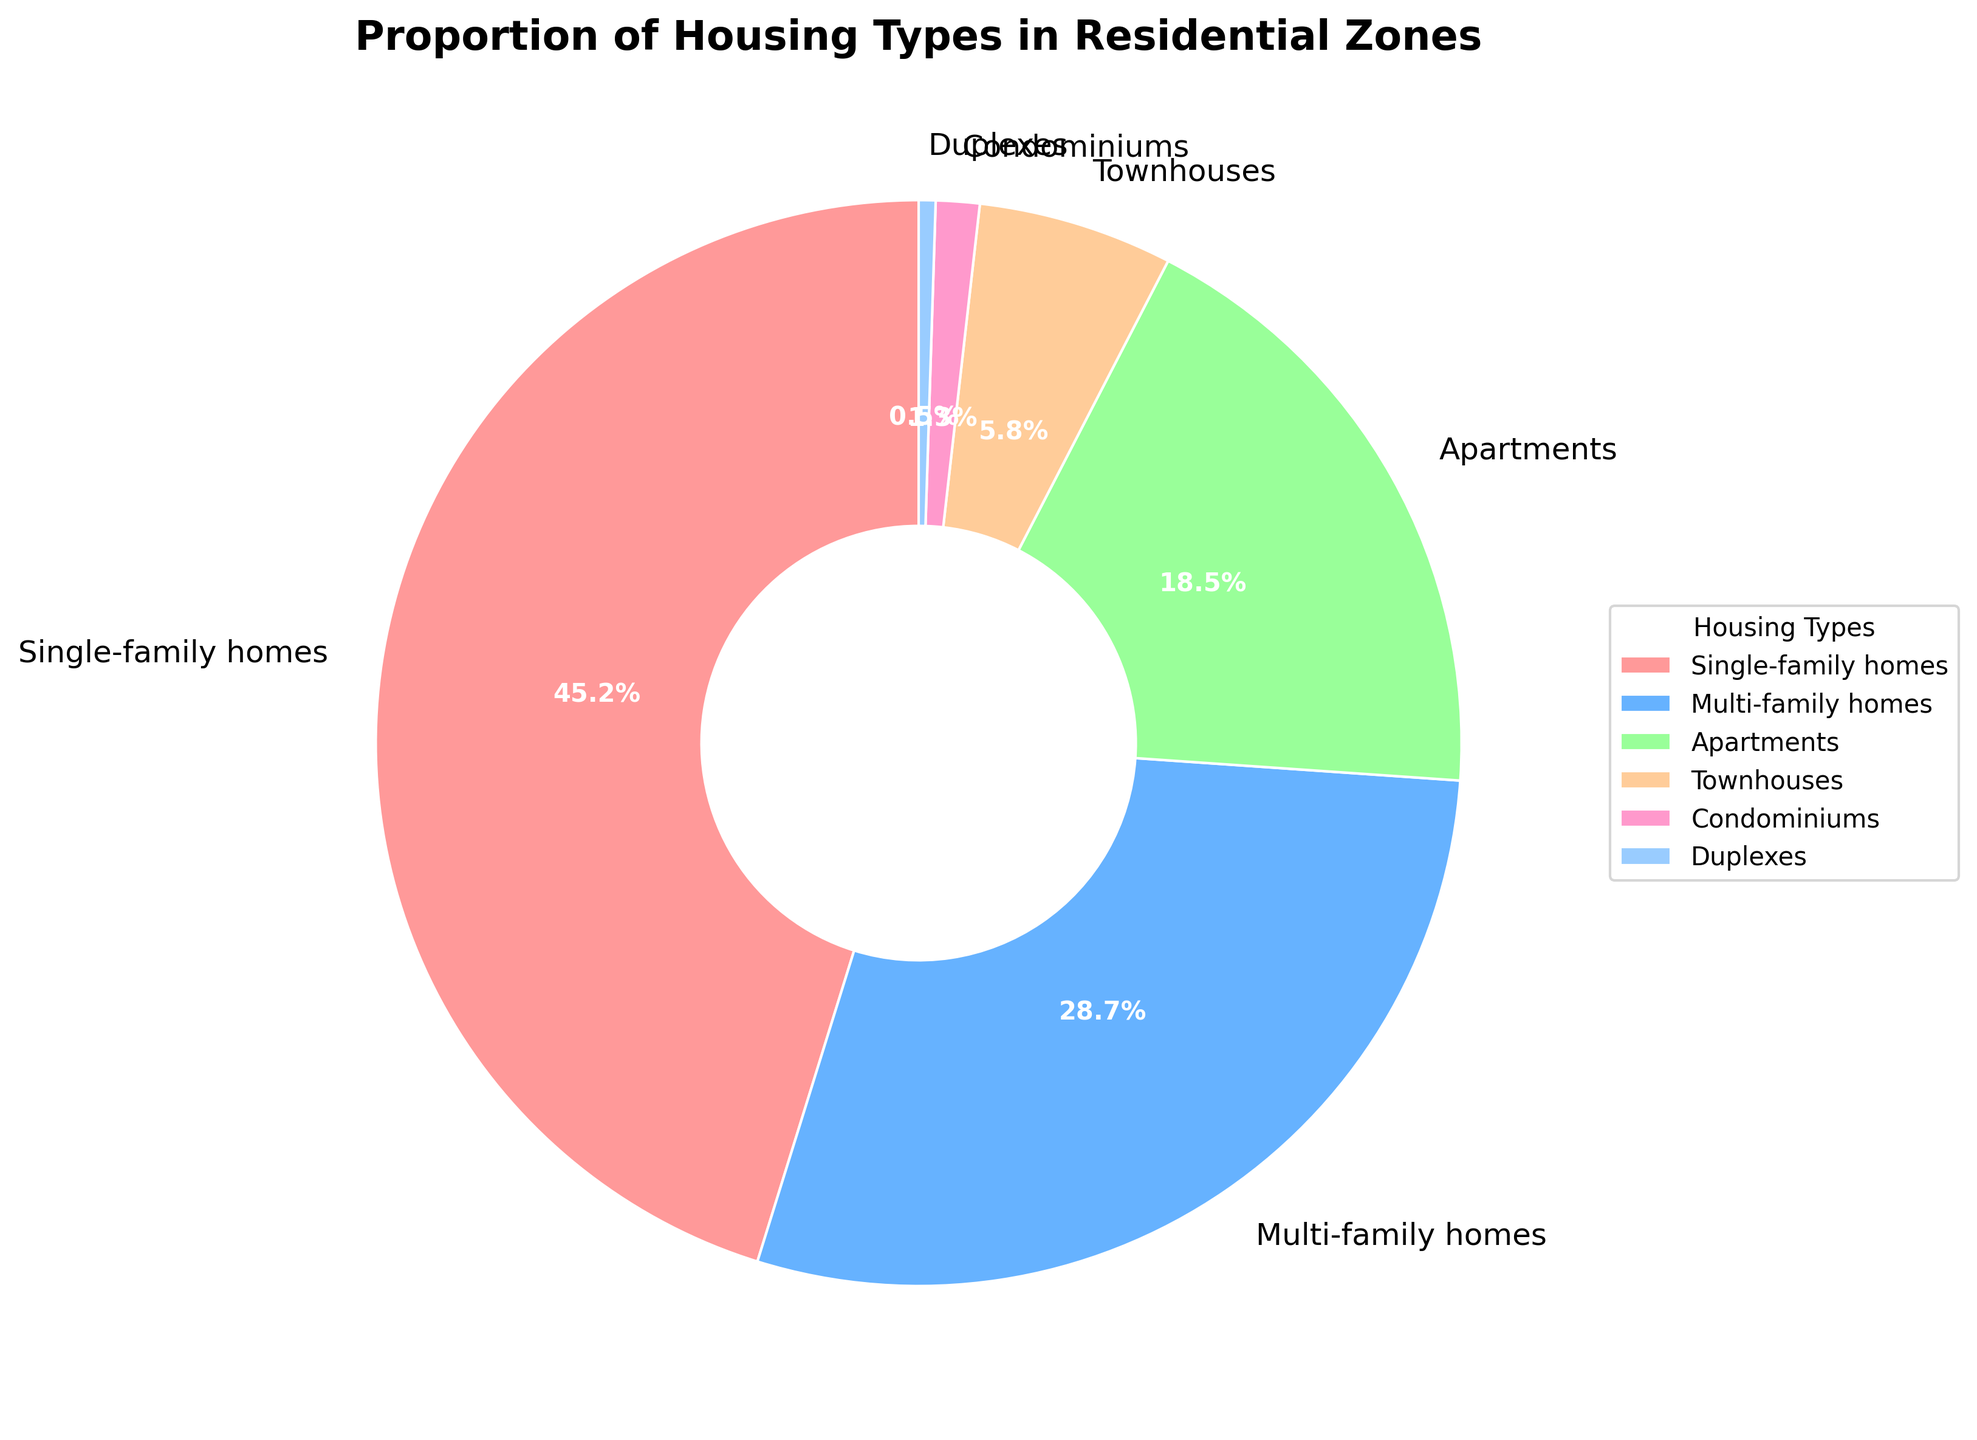What is the percentage of single-family homes? The slice representing single-family homes on the pie chart has the label 45.2%, indicating the percentage of single-family homes.
Answer: 45.2% Which housing type has the smallest proportion in residential zones? The smallest slice on the pie chart represents Duplexes, which has the label 0.5%, indicating it is the smallest proportion.
Answer: Duplexes How much more common are single-family homes compared to multi-family homes? Single-family homes are 45.2% and multi-family homes are 28.7%. The difference is 45.2% - 28.7% = 16.5%.
Answer: 16.5% What is the combined percentage of apartments, townhouses, and condominiums? Apartments are 18.5%, townhouses are 5.8%, and condominiums are 1.3%. The combined percentage is 18.5% + 5.8% + 1.3% = 25.6%.
Answer: 25.6% Which housing types together make up more than half of the residential zones? Adding the percentages of housing types: Single-family homes (45.2%) + Multi-family homes (28.7%) = 73.9%, Multi-family homes (28.7%) + Apartments (18.5%) = 47.2%. Single-family homes alone are already more than half, as it accounts for 45.2% which combined with multi-family homes is above 50%.
Answer: Single-family homes and Multi-family homes Is the percentage of townhouses greater than the percentage of condominiums and duplexes combined? The percentage of townhouses is 5.8%. The combined percentage of condominiums (1.3%) and duplexes (0.5%) is 1.3% + 0.5% = 1.8%. Since 5.8% is greater than 1.8%, the percentage of townhouses is indeed greater.
Answer: Yes What is the proportion of housing types represented with shades of red on the pie chart? Single-family homes and townhouses are represented with shades of red. Their percentages are 45.2% and 5.8%, respectively. The sum is 45.2% + 5.8% = 51%.
Answer: 51% Which two housing types combined make up the second-largest proportion after single-family homes? Single-family homes (45.2%) are the largest. The next largest individual proportions are Multi-family homes (28.7%) and Apartments (18.5%). Their combined total is 28.7% + 18.5% = 47.2%, which is the second-largest.
Answer: Multi-family homes and Apartments 